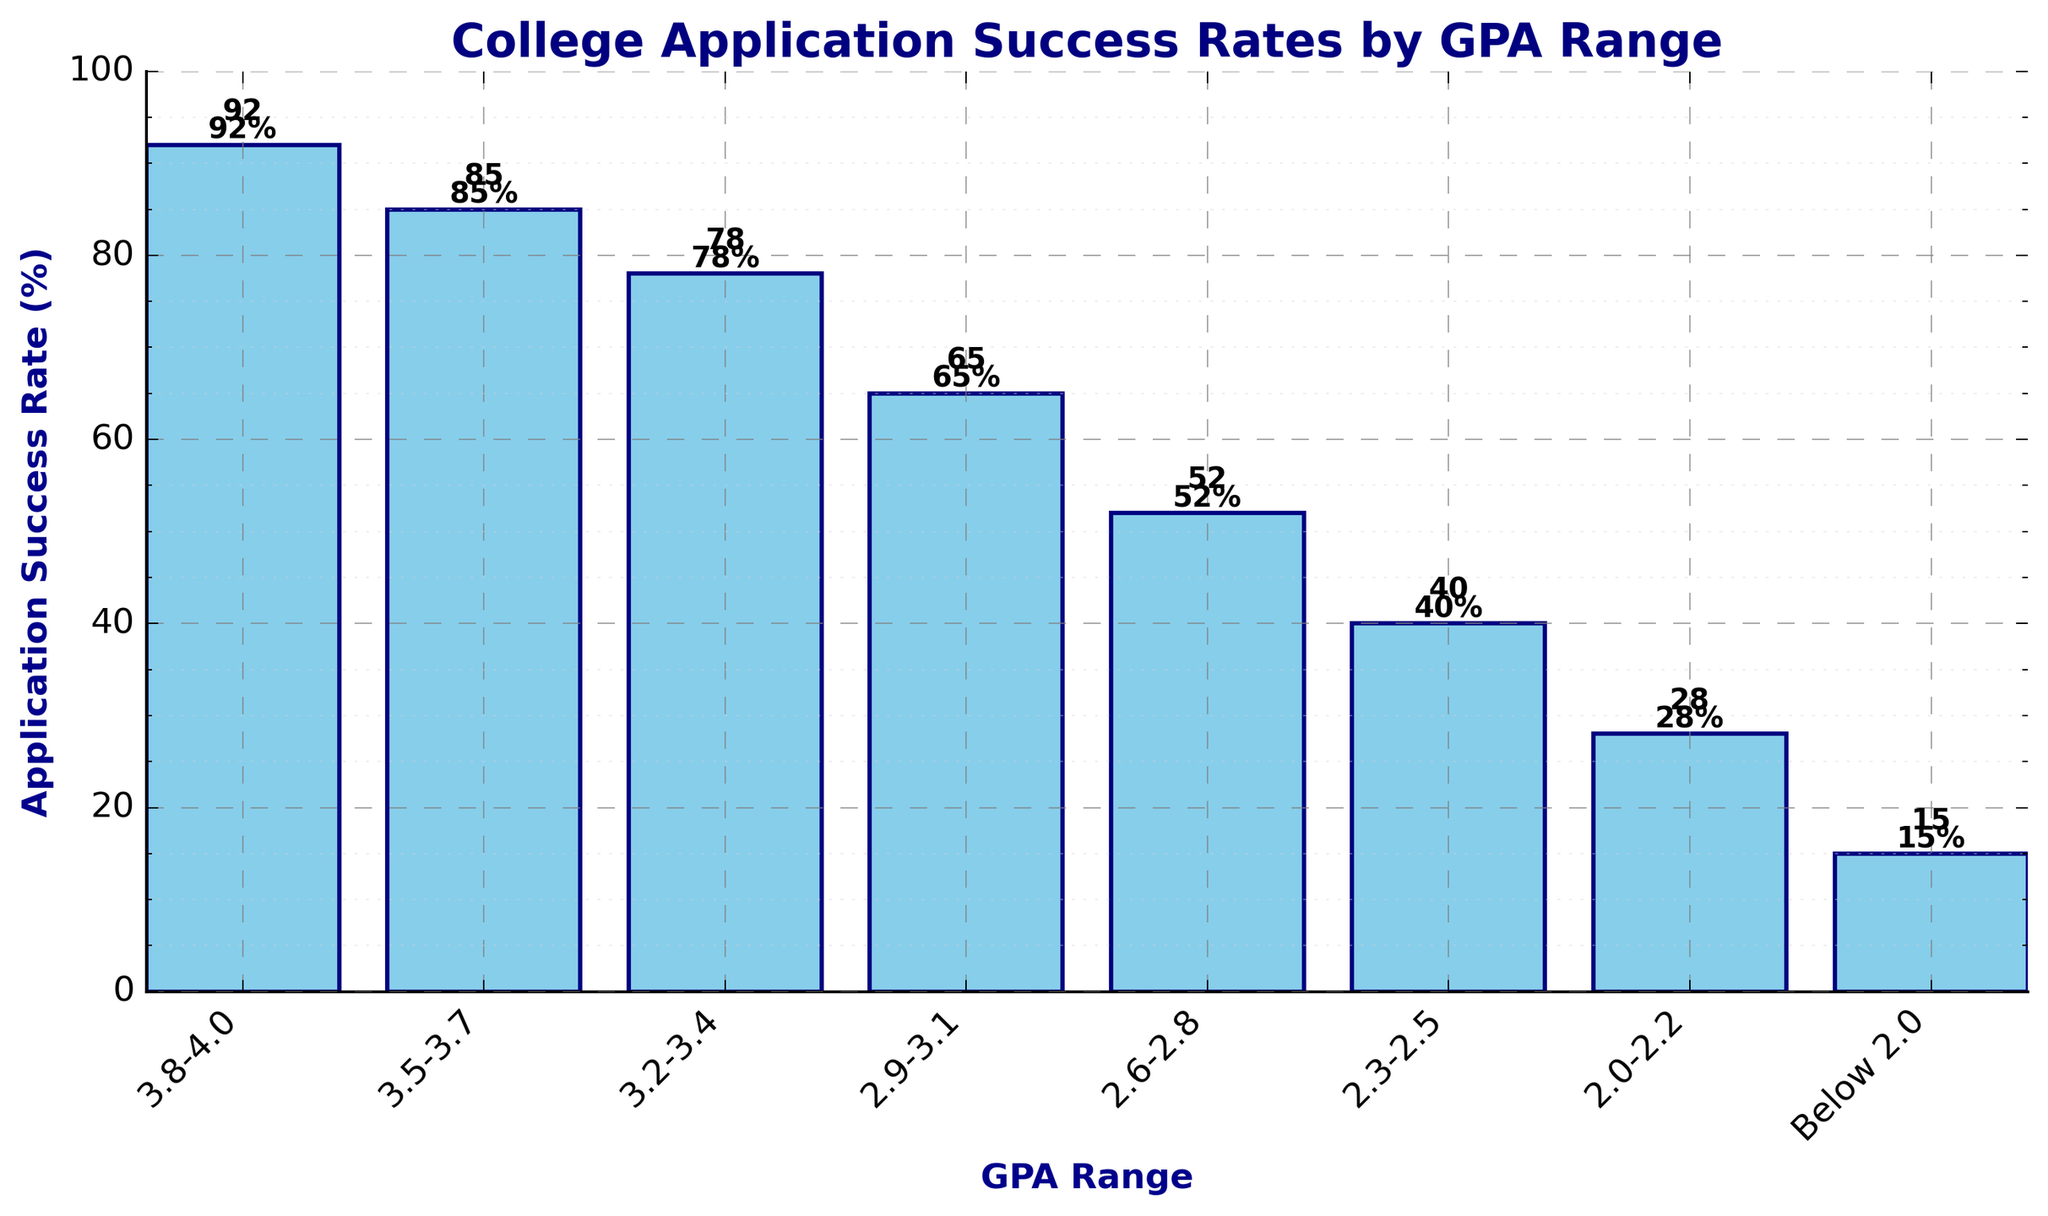what's the application success rate for the GPA range 3.2-3.4? Look at the bar labeled "3.2-3.4" and identify the height of the bar, which represents the success rate. It is labeled as 78%
Answer: 78% which GPA range has the lowest application success rate? Inspect the graph to find the shortest bar, which represents the lowest success rate, labeled as "Below 2.0" with a height of 15%
Answer: Below 2.0 how much higher is the success rate for the GPA range 3.8-4.0 compared to 2.0-2.2? Locate the bars for "3.8-4.0" and "2.0-2.2". The success rates are 92% and 28% respectively. Subtract the lower success rate from the higher one: 92% - 28% = 64%
Answer: 64% what is the difference in application success rate between the GPA ranges 3.5-3.7 and 2.6-2.8? Identify the bars for "3.5-3.7" and "2.6-2.8". The success rates are 85% and 52% respectively. Subtract the success rate of "2.6-2.8" from "3.5-3.7": 85% - 52% = 33%
Answer: 33% which GPA range shows a success rate closest to 50%? Find the bar that is closest to the 50% mark. The bar for "2.6-2.8" is at 52%, which is closest to 50%
Answer: 2.6-2.8 what is the average success rate across all GPA ranges? Add all success rates: 92 + 85 + 78 + 65 + 52 + 40 + 28 + 15 = 455. Divide by the number of GPA ranges (8): 455/8 = 56.875%
Answer: 56.875% between which two consecutive GPA ranges is the largest drop in application success rate observed? Calculate the drop between each consecutive pair of GPA ranges: 
  (3.8-4.0) to (3.5-3.7): 92 - 85 = 7,
  (3.5-3.7) to (3.2-3.4): 85 - 78 = 7,
  (3.2-3.4) to (2.9-3.1): 78 - 65 = 13,
  (2.9-3.1) to (2.6-2.8): 65 - 52 = 13,
  (2.6-2.8) to (2.3-2.5): 52 - 40 = 12,
  (2.3-2.5) to (2.0-2.2): 40 - 28 = 12,
  (2.0-2.2) to (Below 2.0): 28 - 15 = 13.
  The largest drops of 13% are observed between "3.2-3.4" to "2.9-3.1", "2.9-3.1" to "2.6-2.8", and "2.0-2.2" to "Below 2.0"
Answer: "3.2-3.4" to "2.9-3.1" and "2.9-3.1" to "2.6-2.8" and "2.0-2.2" to "Below 2.0" 